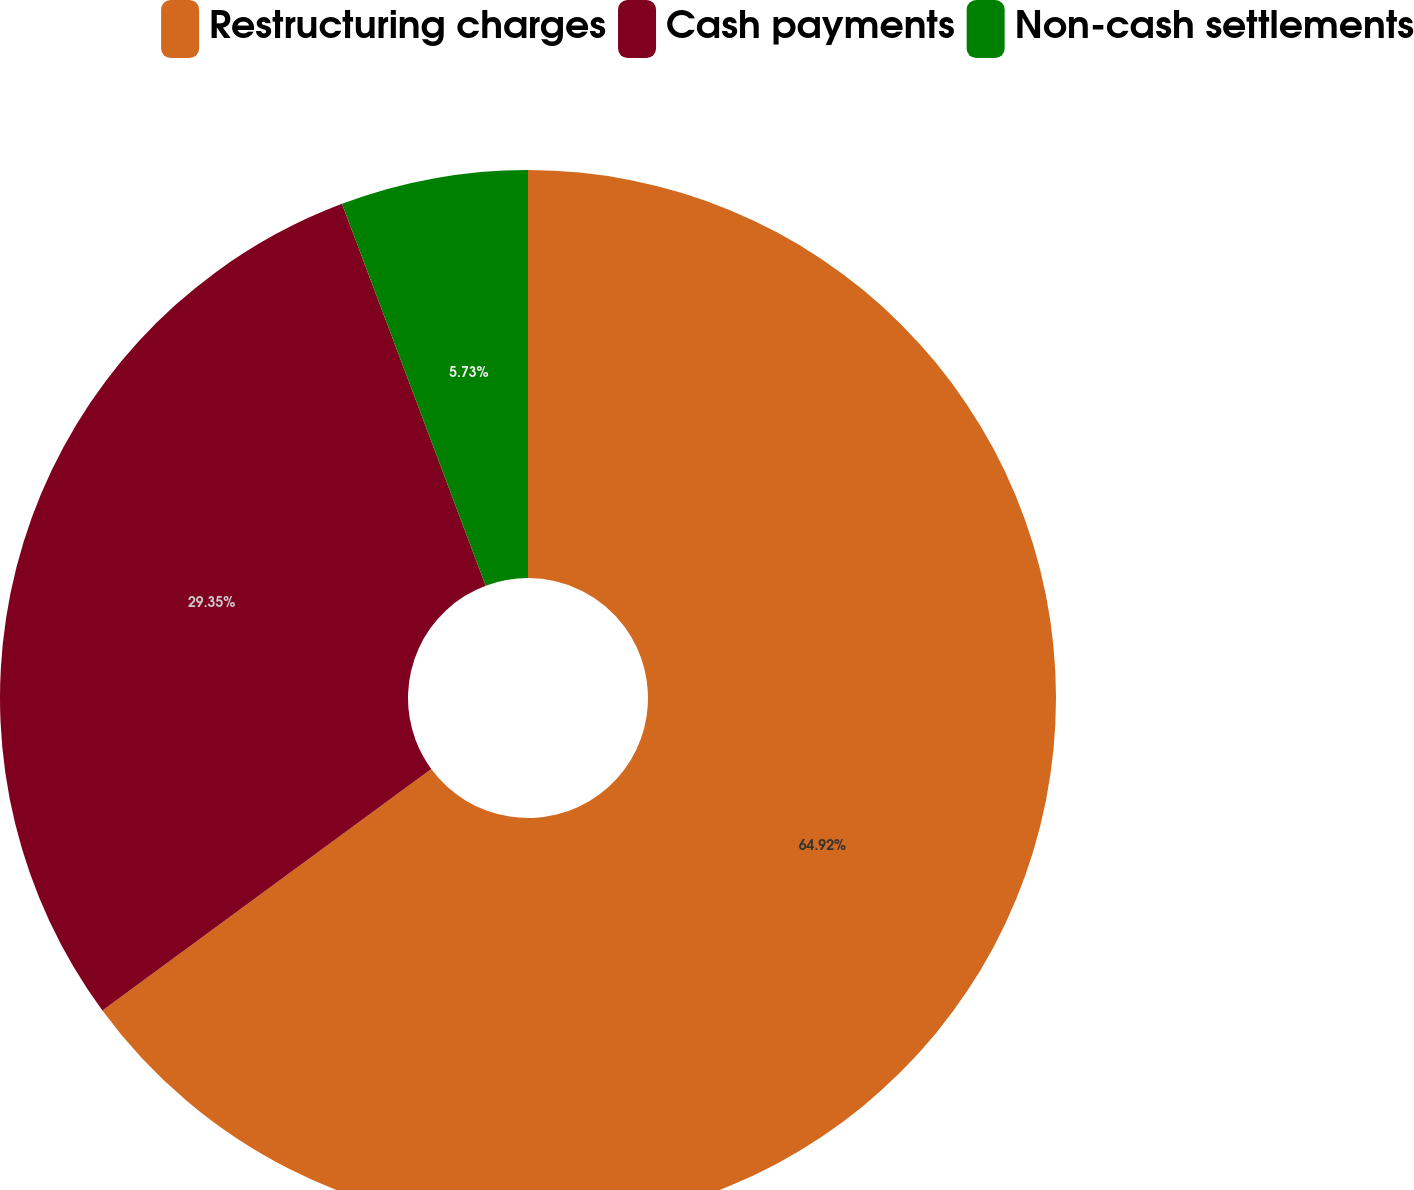Convert chart. <chart><loc_0><loc_0><loc_500><loc_500><pie_chart><fcel>Restructuring charges<fcel>Cash payments<fcel>Non-cash settlements<nl><fcel>64.92%<fcel>29.35%<fcel>5.73%<nl></chart> 